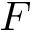Convert formula to latex. <formula><loc_0><loc_0><loc_500><loc_500>F</formula> 